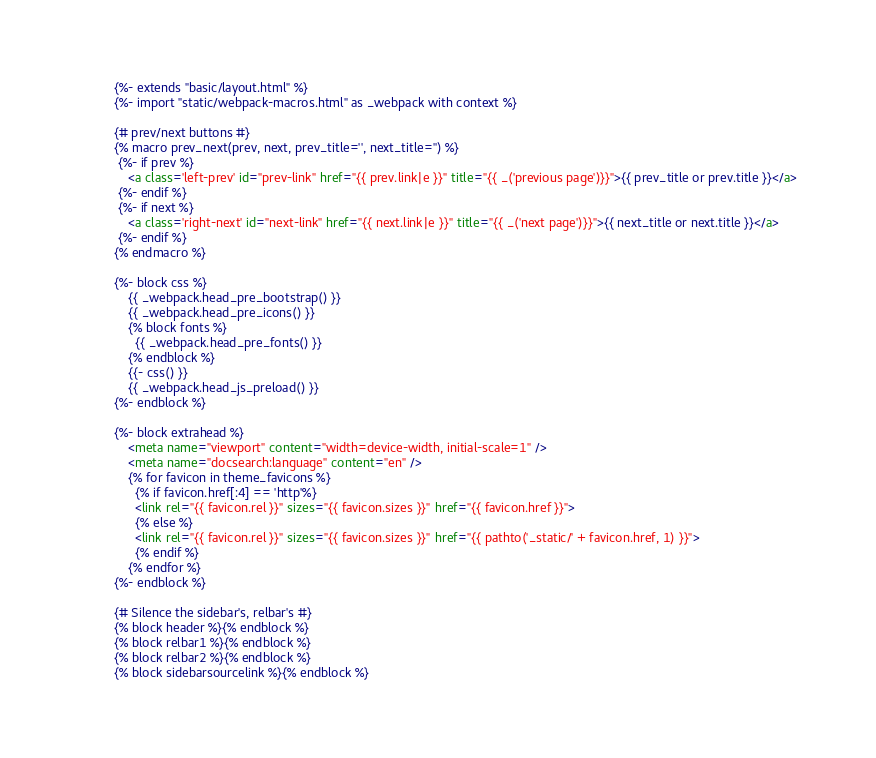<code> <loc_0><loc_0><loc_500><loc_500><_HTML_>{%- extends "basic/layout.html" %}
{%- import "static/webpack-macros.html" as _webpack with context %}

{# prev/next buttons #}
{% macro prev_next(prev, next, prev_title='', next_title='') %}
 {%- if prev %}
    <a class='left-prev' id="prev-link" href="{{ prev.link|e }}" title="{{ _('previous page')}}">{{ prev_title or prev.title }}</a>
 {%- endif %}
 {%- if next %}
    <a class='right-next' id="next-link" href="{{ next.link|e }}" title="{{ _('next page')}}">{{ next_title or next.title }}</a>
 {%- endif %}
{% endmacro %}

{%- block css %}
    {{ _webpack.head_pre_bootstrap() }}
    {{ _webpack.head_pre_icons() }}
    {% block fonts %}
      {{ _webpack.head_pre_fonts() }}
    {% endblock %}
    {{- css() }}
    {{ _webpack.head_js_preload() }}
{%- endblock %}

{%- block extrahead %}
    <meta name="viewport" content="width=device-width, initial-scale=1" />
    <meta name="docsearch:language" content="en" />
    {% for favicon in theme_favicons %}
      {% if favicon.href[:4] == 'http'%}
      <link rel="{{ favicon.rel }}" sizes="{{ favicon.sizes }}" href="{{ favicon.href }}">
      {% else %}
      <link rel="{{ favicon.rel }}" sizes="{{ favicon.sizes }}" href="{{ pathto('_static/' + favicon.href, 1) }}">
      {% endif %}
    {% endfor %}
{%- endblock %}

{# Silence the sidebar's, relbar's #}
{% block header %}{% endblock %}
{% block relbar1 %}{% endblock %}
{% block relbar2 %}{% endblock %}
{% block sidebarsourcelink %}{% endblock %}
</code> 